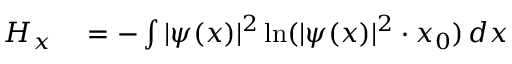<formula> <loc_0><loc_0><loc_500><loc_500>\begin{array} { r l } { H _ { x } } & = - \int | \psi ( x ) | ^ { 2 } \ln ( | \psi ( x ) | ^ { 2 } \cdot x _ { 0 } ) \, d x } \end{array}</formula> 